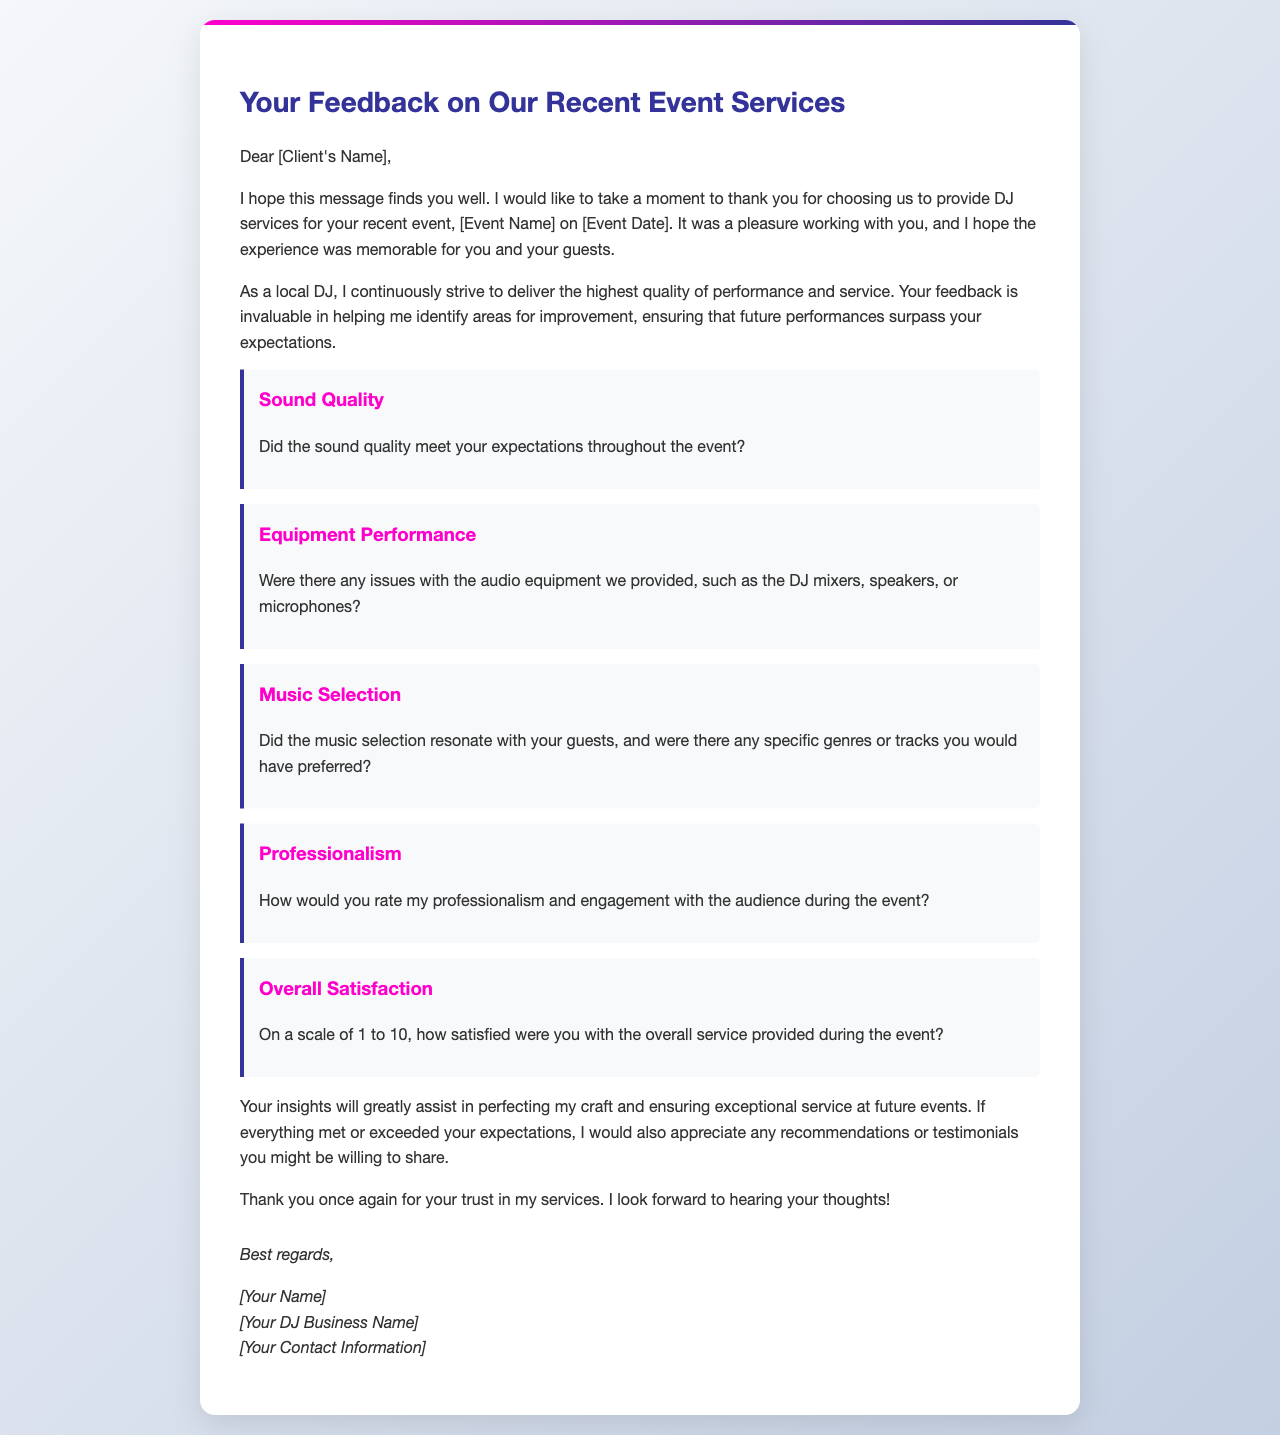What is the title of the document? The title, visible at the top of the letter, indicates the purpose of the communication regarding feedback.
Answer: Your Feedback on Our Recent Event Services Who is the recipient of the letter? The letter starts with a greeting directed at the client, allowing us to identify who the letter is addressed to.
Answer: [Client's Name] What event is referenced in the letter? The document specifies the event for which the services were provided, highlighting its importance in the context.
Answer: [Event Name] What date is mentioned in the letter? The letter references the specific time when the event occurred, providing context for the feedback requested.
Answer: [Event Date] On what scale is the overall satisfaction measured? The document explicitly states the method of evaluation used for gauging overall satisfaction in the event.
Answer: 1 to 10 What is requested in the section about sound quality? This section asks the client to assess a specific aspect of the performance quality regarding the sound.
Answer: Did the sound quality meet your expectations throughout the event? What kind of feedback does the DJ request regarding professionalism? The letter prompts the client to evaluate specific behavioral aspects during the event.
Answer: How would you rate my professionalism and engagement with the audience during the event? What is the goal of requesting feedback in this letter? The purpose of the document as stated indicates how the feedback will be used for future improvements.
Answer: Ensuring exceptional service at future events What does the DJ thank the client for at the beginning of the letter? The opening expresses gratitude for a specific choice made by the client, setting a positive tone.
Answer: Choosing us to provide DJ services What does the signature section of the letter include? This part of the document typically contains personal identification for following up or future communications.
Answer: [Your Name], [Your DJ Business Name], [Your Contact Information] 